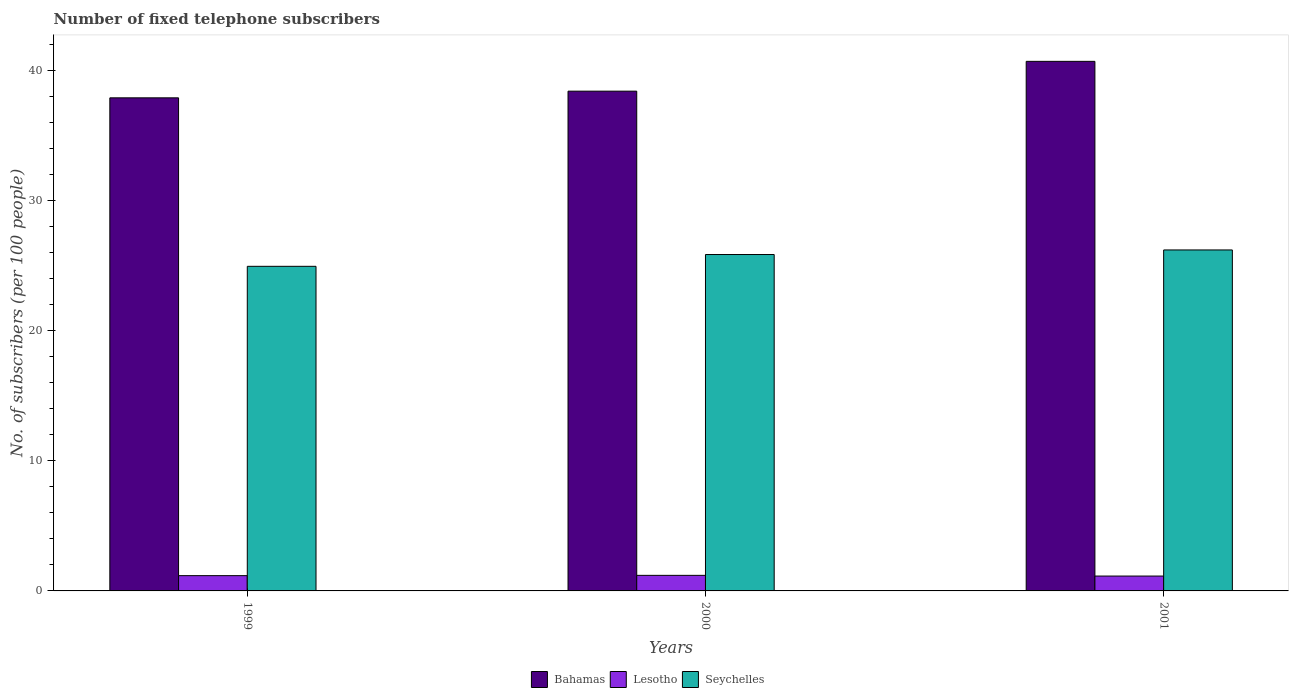How many different coloured bars are there?
Keep it short and to the point. 3. How many groups of bars are there?
Provide a short and direct response. 3. Are the number of bars per tick equal to the number of legend labels?
Keep it short and to the point. Yes. Are the number of bars on each tick of the X-axis equal?
Ensure brevity in your answer.  Yes. In how many cases, is the number of bars for a given year not equal to the number of legend labels?
Make the answer very short. 0. What is the number of fixed telephone subscribers in Lesotho in 2000?
Your response must be concise. 1.2. Across all years, what is the maximum number of fixed telephone subscribers in Seychelles?
Keep it short and to the point. 26.2. Across all years, what is the minimum number of fixed telephone subscribers in Lesotho?
Make the answer very short. 1.14. What is the total number of fixed telephone subscribers in Bahamas in the graph?
Your response must be concise. 116.99. What is the difference between the number of fixed telephone subscribers in Lesotho in 1999 and that in 2000?
Your answer should be very brief. -0.02. What is the difference between the number of fixed telephone subscribers in Seychelles in 2000 and the number of fixed telephone subscribers in Lesotho in 1999?
Your response must be concise. 24.68. What is the average number of fixed telephone subscribers in Lesotho per year?
Your answer should be compact. 1.17. In the year 1999, what is the difference between the number of fixed telephone subscribers in Bahamas and number of fixed telephone subscribers in Seychelles?
Provide a short and direct response. 12.95. In how many years, is the number of fixed telephone subscribers in Lesotho greater than 2?
Offer a very short reply. 0. What is the ratio of the number of fixed telephone subscribers in Bahamas in 2000 to that in 2001?
Make the answer very short. 0.94. Is the number of fixed telephone subscribers in Lesotho in 1999 less than that in 2001?
Your response must be concise. No. Is the difference between the number of fixed telephone subscribers in Bahamas in 2000 and 2001 greater than the difference between the number of fixed telephone subscribers in Seychelles in 2000 and 2001?
Make the answer very short. No. What is the difference between the highest and the second highest number of fixed telephone subscribers in Lesotho?
Ensure brevity in your answer.  0.02. What is the difference between the highest and the lowest number of fixed telephone subscribers in Lesotho?
Provide a short and direct response. 0.05. In how many years, is the number of fixed telephone subscribers in Bahamas greater than the average number of fixed telephone subscribers in Bahamas taken over all years?
Give a very brief answer. 1. What does the 1st bar from the left in 2001 represents?
Offer a very short reply. Bahamas. What does the 3rd bar from the right in 1999 represents?
Provide a succinct answer. Bahamas. How many bars are there?
Make the answer very short. 9. Are all the bars in the graph horizontal?
Provide a succinct answer. No. Where does the legend appear in the graph?
Provide a succinct answer. Bottom center. How many legend labels are there?
Your response must be concise. 3. How are the legend labels stacked?
Give a very brief answer. Horizontal. What is the title of the graph?
Your answer should be compact. Number of fixed telephone subscribers. What is the label or title of the Y-axis?
Your answer should be compact. No. of subscribers (per 100 people). What is the No. of subscribers (per 100 people) of Bahamas in 1999?
Your answer should be compact. 37.89. What is the No. of subscribers (per 100 people) in Lesotho in 1999?
Offer a terse response. 1.17. What is the No. of subscribers (per 100 people) of Seychelles in 1999?
Ensure brevity in your answer.  24.94. What is the No. of subscribers (per 100 people) in Bahamas in 2000?
Your answer should be compact. 38.4. What is the No. of subscribers (per 100 people) of Lesotho in 2000?
Give a very brief answer. 1.2. What is the No. of subscribers (per 100 people) in Seychelles in 2000?
Offer a terse response. 25.85. What is the No. of subscribers (per 100 people) of Bahamas in 2001?
Your response must be concise. 40.69. What is the No. of subscribers (per 100 people) of Lesotho in 2001?
Your answer should be very brief. 1.14. What is the No. of subscribers (per 100 people) in Seychelles in 2001?
Give a very brief answer. 26.2. Across all years, what is the maximum No. of subscribers (per 100 people) of Bahamas?
Offer a very short reply. 40.69. Across all years, what is the maximum No. of subscribers (per 100 people) in Lesotho?
Make the answer very short. 1.2. Across all years, what is the maximum No. of subscribers (per 100 people) of Seychelles?
Offer a very short reply. 26.2. Across all years, what is the minimum No. of subscribers (per 100 people) of Bahamas?
Your answer should be very brief. 37.89. Across all years, what is the minimum No. of subscribers (per 100 people) in Lesotho?
Keep it short and to the point. 1.14. Across all years, what is the minimum No. of subscribers (per 100 people) of Seychelles?
Ensure brevity in your answer.  24.94. What is the total No. of subscribers (per 100 people) in Bahamas in the graph?
Make the answer very short. 116.99. What is the total No. of subscribers (per 100 people) in Lesotho in the graph?
Make the answer very short. 3.51. What is the total No. of subscribers (per 100 people) of Seychelles in the graph?
Provide a succinct answer. 76.99. What is the difference between the No. of subscribers (per 100 people) of Bahamas in 1999 and that in 2000?
Offer a very short reply. -0.51. What is the difference between the No. of subscribers (per 100 people) in Lesotho in 1999 and that in 2000?
Offer a very short reply. -0.02. What is the difference between the No. of subscribers (per 100 people) in Seychelles in 1999 and that in 2000?
Your answer should be very brief. -0.91. What is the difference between the No. of subscribers (per 100 people) of Bahamas in 1999 and that in 2001?
Offer a terse response. -2.8. What is the difference between the No. of subscribers (per 100 people) of Lesotho in 1999 and that in 2001?
Provide a short and direct response. 0.03. What is the difference between the No. of subscribers (per 100 people) in Seychelles in 1999 and that in 2001?
Provide a succinct answer. -1.26. What is the difference between the No. of subscribers (per 100 people) in Bahamas in 2000 and that in 2001?
Your answer should be compact. -2.29. What is the difference between the No. of subscribers (per 100 people) of Lesotho in 2000 and that in 2001?
Provide a succinct answer. 0.05. What is the difference between the No. of subscribers (per 100 people) of Seychelles in 2000 and that in 2001?
Your answer should be compact. -0.35. What is the difference between the No. of subscribers (per 100 people) in Bahamas in 1999 and the No. of subscribers (per 100 people) in Lesotho in 2000?
Your answer should be very brief. 36.69. What is the difference between the No. of subscribers (per 100 people) in Bahamas in 1999 and the No. of subscribers (per 100 people) in Seychelles in 2000?
Give a very brief answer. 12.04. What is the difference between the No. of subscribers (per 100 people) in Lesotho in 1999 and the No. of subscribers (per 100 people) in Seychelles in 2000?
Make the answer very short. -24.68. What is the difference between the No. of subscribers (per 100 people) of Bahamas in 1999 and the No. of subscribers (per 100 people) of Lesotho in 2001?
Make the answer very short. 36.75. What is the difference between the No. of subscribers (per 100 people) in Bahamas in 1999 and the No. of subscribers (per 100 people) in Seychelles in 2001?
Your response must be concise. 11.69. What is the difference between the No. of subscribers (per 100 people) of Lesotho in 1999 and the No. of subscribers (per 100 people) of Seychelles in 2001?
Ensure brevity in your answer.  -25.03. What is the difference between the No. of subscribers (per 100 people) of Bahamas in 2000 and the No. of subscribers (per 100 people) of Lesotho in 2001?
Provide a short and direct response. 37.26. What is the difference between the No. of subscribers (per 100 people) of Bahamas in 2000 and the No. of subscribers (per 100 people) of Seychelles in 2001?
Offer a terse response. 12.2. What is the difference between the No. of subscribers (per 100 people) in Lesotho in 2000 and the No. of subscribers (per 100 people) in Seychelles in 2001?
Provide a succinct answer. -25. What is the average No. of subscribers (per 100 people) of Bahamas per year?
Keep it short and to the point. 39. What is the average No. of subscribers (per 100 people) in Lesotho per year?
Keep it short and to the point. 1.17. What is the average No. of subscribers (per 100 people) in Seychelles per year?
Offer a very short reply. 25.66. In the year 1999, what is the difference between the No. of subscribers (per 100 people) of Bahamas and No. of subscribers (per 100 people) of Lesotho?
Ensure brevity in your answer.  36.72. In the year 1999, what is the difference between the No. of subscribers (per 100 people) in Bahamas and No. of subscribers (per 100 people) in Seychelles?
Ensure brevity in your answer.  12.95. In the year 1999, what is the difference between the No. of subscribers (per 100 people) in Lesotho and No. of subscribers (per 100 people) in Seychelles?
Provide a short and direct response. -23.77. In the year 2000, what is the difference between the No. of subscribers (per 100 people) of Bahamas and No. of subscribers (per 100 people) of Lesotho?
Make the answer very short. 37.21. In the year 2000, what is the difference between the No. of subscribers (per 100 people) in Bahamas and No. of subscribers (per 100 people) in Seychelles?
Provide a short and direct response. 12.55. In the year 2000, what is the difference between the No. of subscribers (per 100 people) of Lesotho and No. of subscribers (per 100 people) of Seychelles?
Your response must be concise. -24.65. In the year 2001, what is the difference between the No. of subscribers (per 100 people) in Bahamas and No. of subscribers (per 100 people) in Lesotho?
Provide a succinct answer. 39.55. In the year 2001, what is the difference between the No. of subscribers (per 100 people) of Bahamas and No. of subscribers (per 100 people) of Seychelles?
Your answer should be compact. 14.49. In the year 2001, what is the difference between the No. of subscribers (per 100 people) in Lesotho and No. of subscribers (per 100 people) in Seychelles?
Offer a terse response. -25.06. What is the ratio of the No. of subscribers (per 100 people) in Bahamas in 1999 to that in 2000?
Your answer should be compact. 0.99. What is the ratio of the No. of subscribers (per 100 people) of Lesotho in 1999 to that in 2000?
Provide a succinct answer. 0.98. What is the ratio of the No. of subscribers (per 100 people) of Seychelles in 1999 to that in 2000?
Provide a succinct answer. 0.96. What is the ratio of the No. of subscribers (per 100 people) in Bahamas in 1999 to that in 2001?
Your answer should be compact. 0.93. What is the ratio of the No. of subscribers (per 100 people) in Lesotho in 1999 to that in 2001?
Your answer should be very brief. 1.03. What is the ratio of the No. of subscribers (per 100 people) in Seychelles in 1999 to that in 2001?
Offer a very short reply. 0.95. What is the ratio of the No. of subscribers (per 100 people) in Bahamas in 2000 to that in 2001?
Offer a very short reply. 0.94. What is the ratio of the No. of subscribers (per 100 people) in Lesotho in 2000 to that in 2001?
Keep it short and to the point. 1.05. What is the ratio of the No. of subscribers (per 100 people) of Seychelles in 2000 to that in 2001?
Make the answer very short. 0.99. What is the difference between the highest and the second highest No. of subscribers (per 100 people) in Bahamas?
Your answer should be very brief. 2.29. What is the difference between the highest and the second highest No. of subscribers (per 100 people) of Lesotho?
Your answer should be compact. 0.02. What is the difference between the highest and the second highest No. of subscribers (per 100 people) of Seychelles?
Provide a short and direct response. 0.35. What is the difference between the highest and the lowest No. of subscribers (per 100 people) in Bahamas?
Offer a very short reply. 2.8. What is the difference between the highest and the lowest No. of subscribers (per 100 people) in Lesotho?
Your answer should be very brief. 0.05. What is the difference between the highest and the lowest No. of subscribers (per 100 people) in Seychelles?
Make the answer very short. 1.26. 